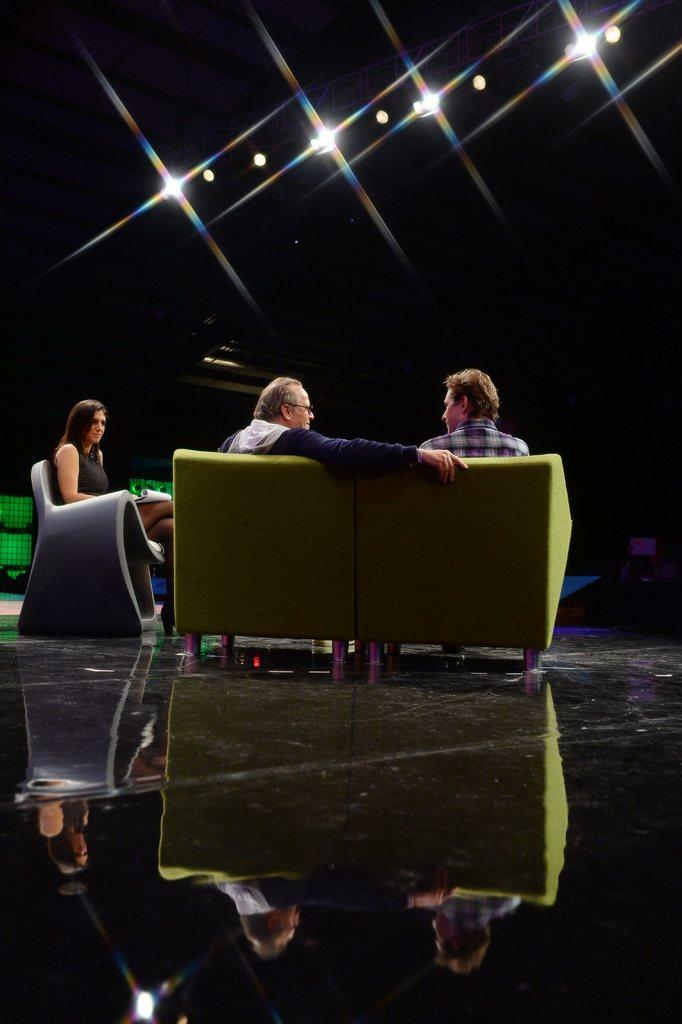How many people are in the image? There are three individuals in the image, two men and a woman. What are the people in the image doing? The three individuals are sitting on sofas. What can be seen in the background of the image? There are lights visible in the background of the image. What type of suit is the rainstorm wearing in the image? There is no rainstorm or suit present in the image. What impulse might have caused the individuals to sit on the sofas in the image? The image does not provide information about the individuals' motivations or impulses for sitting on the sofas. 